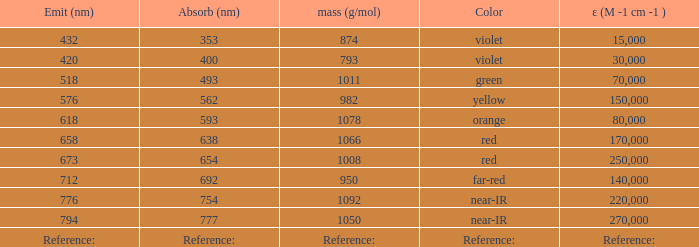What is the Absorbtion (in nanometers) of the color Violet with an emission of 432 nm? 353.0. 